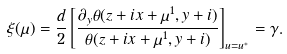<formula> <loc_0><loc_0><loc_500><loc_500>\xi ( \mu ) = \frac { d } { 2 } \left [ \frac { \partial _ { y } \theta ( z + i x + \mu ^ { 1 } , y + i ) } { \theta ( z + i x + \mu ^ { 1 } , y + i ) } \right ] _ { u = u ^ { * } } = \gamma .</formula> 